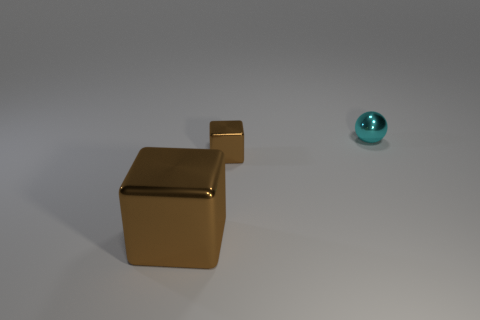What materials do the objects in the image appear to be made of? The objects in the image appear to be rendered with different types of surfaces; the larger gold-colored shapes have a metallic finish, suggesting a reflective and smooth texture, while the cyan sphere has a matte finish, indicating a less reflective and possible plastic-like material. 